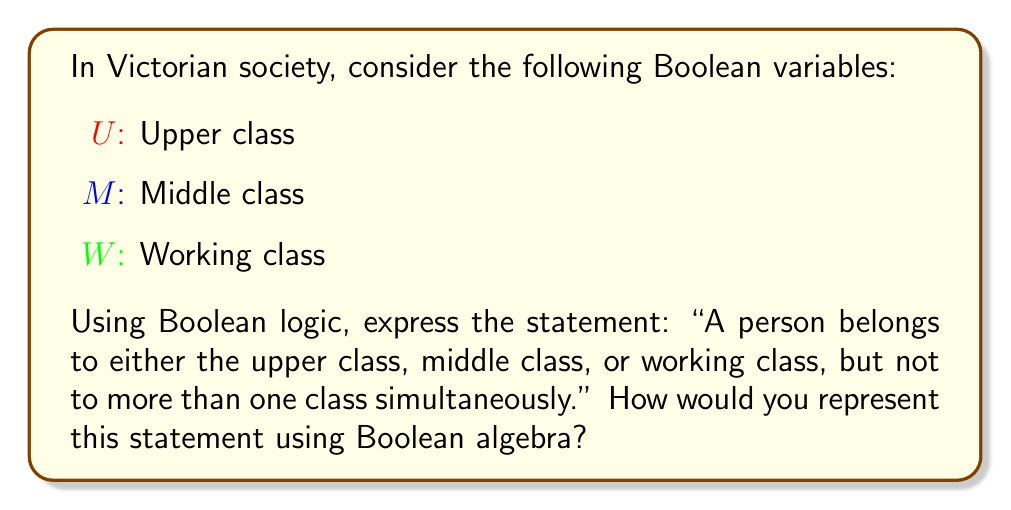Teach me how to tackle this problem. To represent this statement using Boolean algebra, we need to consider the following steps:

1. First, we need to express that a person belongs to at least one of the classes:
   $$(U \lor M \lor W)$$

2. Next, we need to ensure that a person doesn't belong to more than one class simultaneously. We can express this by stating that it's not possible to belong to any two classes at the same time:
   $$\neg(U \land M) \land \neg(U \land W) \land \neg(M \land W)$$

3. Combining these two conditions using the AND operator (∧), we get:
   $$(U \lor M \lor W) \land \neg(U \land M) \land \neg(U \land W) \land \neg(M \land W)$$

4. This expression can be simplified using the exclusive OR (XOR) operator, denoted by ⊕. The XOR operation is true when exactly one of its operands is true, which perfectly captures our requirement:
   $$U \oplus M \oplus W$$

This final expression represents the statement that a person belongs to exactly one of the three social classes in Victorian society.
Answer: $$U \oplus M \oplus W$$ 